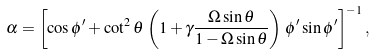<formula> <loc_0><loc_0><loc_500><loc_500>\alpha = \left [ \cos { \phi ^ { \prime } } + \cot ^ { 2 } \theta \, \left ( 1 + \gamma \frac { \Omega \sin { \theta } } { 1 - \Omega \sin { \theta } } \right ) \, \phi ^ { \prime } \sin { \phi ^ { \prime } } \right ] ^ { - 1 } ,</formula> 